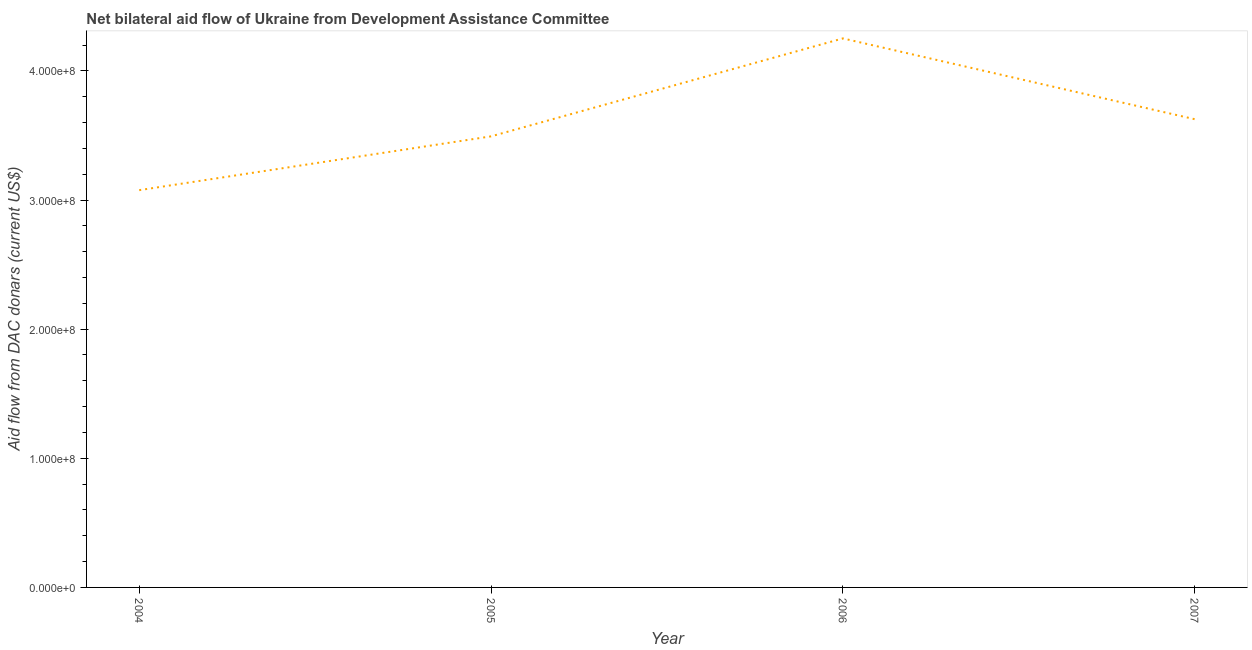What is the net bilateral aid flows from dac donors in 2007?
Offer a terse response. 3.63e+08. Across all years, what is the maximum net bilateral aid flows from dac donors?
Your answer should be compact. 4.25e+08. Across all years, what is the minimum net bilateral aid flows from dac donors?
Give a very brief answer. 3.08e+08. In which year was the net bilateral aid flows from dac donors maximum?
Your answer should be compact. 2006. What is the sum of the net bilateral aid flows from dac donors?
Offer a terse response. 1.44e+09. What is the difference between the net bilateral aid flows from dac donors in 2005 and 2006?
Your answer should be compact. -7.58e+07. What is the average net bilateral aid flows from dac donors per year?
Offer a terse response. 3.61e+08. What is the median net bilateral aid flows from dac donors?
Your answer should be compact. 3.56e+08. In how many years, is the net bilateral aid flows from dac donors greater than 360000000 US$?
Provide a succinct answer. 2. What is the ratio of the net bilateral aid flows from dac donors in 2006 to that in 2007?
Provide a short and direct response. 1.17. Is the net bilateral aid flows from dac donors in 2006 less than that in 2007?
Provide a short and direct response. No. Is the difference between the net bilateral aid flows from dac donors in 2005 and 2006 greater than the difference between any two years?
Offer a terse response. No. What is the difference between the highest and the second highest net bilateral aid flows from dac donors?
Offer a very short reply. 6.26e+07. Is the sum of the net bilateral aid flows from dac donors in 2004 and 2005 greater than the maximum net bilateral aid flows from dac donors across all years?
Give a very brief answer. Yes. What is the difference between the highest and the lowest net bilateral aid flows from dac donors?
Make the answer very short. 1.18e+08. How many years are there in the graph?
Your response must be concise. 4. Are the values on the major ticks of Y-axis written in scientific E-notation?
Your answer should be very brief. Yes. Does the graph contain grids?
Ensure brevity in your answer.  No. What is the title of the graph?
Provide a short and direct response. Net bilateral aid flow of Ukraine from Development Assistance Committee. What is the label or title of the X-axis?
Your response must be concise. Year. What is the label or title of the Y-axis?
Ensure brevity in your answer.  Aid flow from DAC donars (current US$). What is the Aid flow from DAC donars (current US$) in 2004?
Give a very brief answer. 3.08e+08. What is the Aid flow from DAC donars (current US$) of 2005?
Your response must be concise. 3.49e+08. What is the Aid flow from DAC donars (current US$) in 2006?
Provide a succinct answer. 4.25e+08. What is the Aid flow from DAC donars (current US$) of 2007?
Your answer should be very brief. 3.63e+08. What is the difference between the Aid flow from DAC donars (current US$) in 2004 and 2005?
Ensure brevity in your answer.  -4.17e+07. What is the difference between the Aid flow from DAC donars (current US$) in 2004 and 2006?
Give a very brief answer. -1.18e+08. What is the difference between the Aid flow from DAC donars (current US$) in 2004 and 2007?
Provide a short and direct response. -5.50e+07. What is the difference between the Aid flow from DAC donars (current US$) in 2005 and 2006?
Your answer should be compact. -7.58e+07. What is the difference between the Aid flow from DAC donars (current US$) in 2005 and 2007?
Keep it short and to the point. -1.33e+07. What is the difference between the Aid flow from DAC donars (current US$) in 2006 and 2007?
Make the answer very short. 6.26e+07. What is the ratio of the Aid flow from DAC donars (current US$) in 2004 to that in 2005?
Make the answer very short. 0.88. What is the ratio of the Aid flow from DAC donars (current US$) in 2004 to that in 2006?
Provide a succinct answer. 0.72. What is the ratio of the Aid flow from DAC donars (current US$) in 2004 to that in 2007?
Your answer should be compact. 0.85. What is the ratio of the Aid flow from DAC donars (current US$) in 2005 to that in 2006?
Your response must be concise. 0.82. What is the ratio of the Aid flow from DAC donars (current US$) in 2005 to that in 2007?
Make the answer very short. 0.96. What is the ratio of the Aid flow from DAC donars (current US$) in 2006 to that in 2007?
Ensure brevity in your answer.  1.17. 